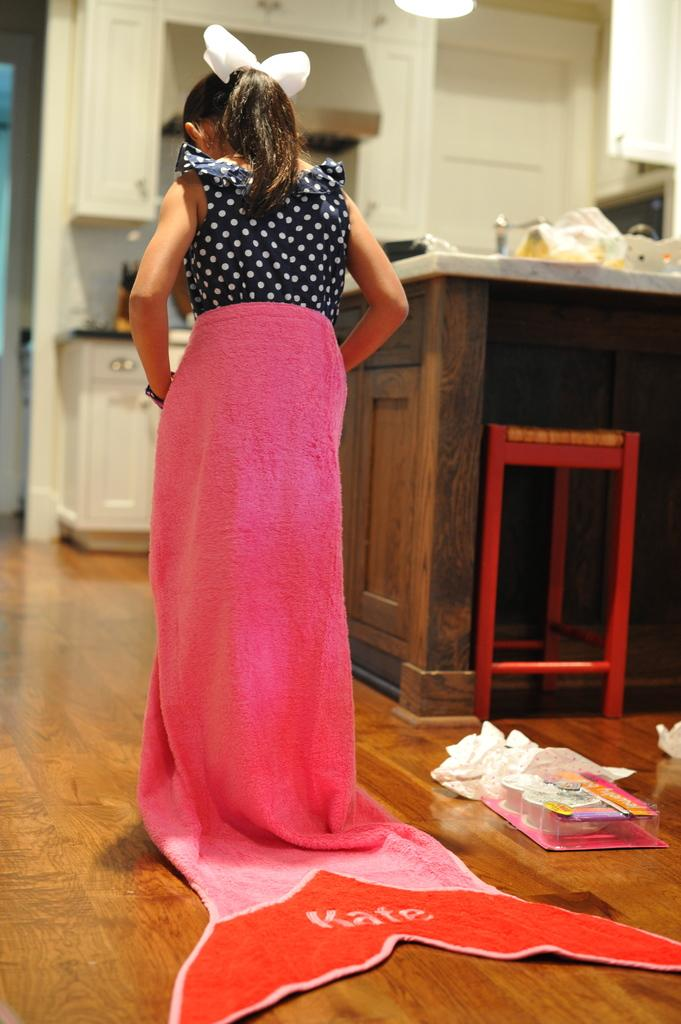Who is in the picture? There is a girl in the picture. What is the girl wearing? The girl is wearing a pink towel. Where is the girl located in the image? The girl is standing in the kitchen. What can be seen in the background of the image? There is a table and a white door visible in the background. What type of amusement can be seen in the image? There is no amusement present in the image; it features a girl standing in the kitchen wearing a pink towel. What health benefits can be gained from the button in the image? There is no button present in the image, so it is not possible to determine any health benefits. 